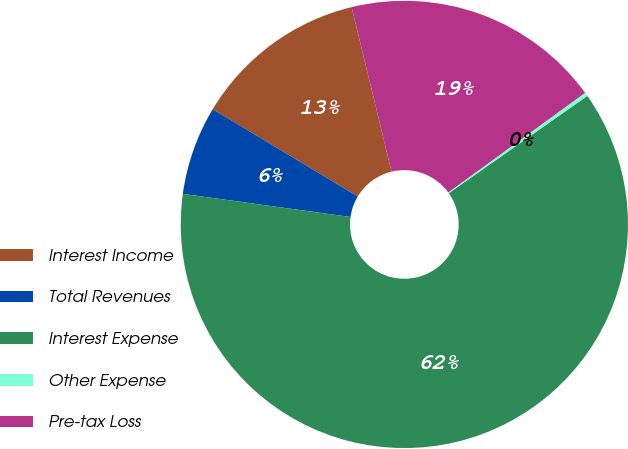Convert chart. <chart><loc_0><loc_0><loc_500><loc_500><pie_chart><fcel>Interest Income<fcel>Total Revenues<fcel>Interest Expense<fcel>Other Expense<fcel>Pre-tax Loss<nl><fcel>12.6%<fcel>6.43%<fcel>61.93%<fcel>0.27%<fcel>18.77%<nl></chart> 